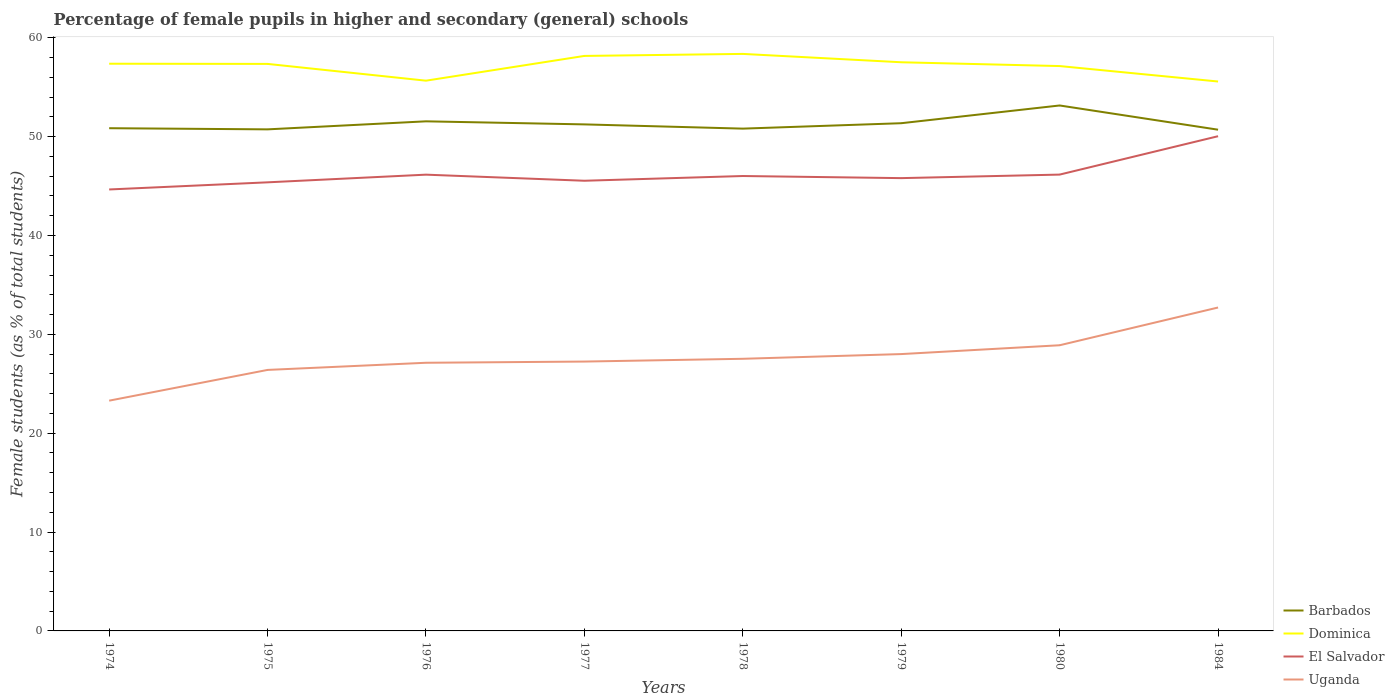Is the number of lines equal to the number of legend labels?
Your response must be concise. Yes. Across all years, what is the maximum percentage of female pupils in higher and secondary schools in Barbados?
Your answer should be compact. 50.71. In which year was the percentage of female pupils in higher and secondary schools in Barbados maximum?
Keep it short and to the point. 1984. What is the total percentage of female pupils in higher and secondary schools in Dominica in the graph?
Provide a succinct answer. -0.15. What is the difference between the highest and the second highest percentage of female pupils in higher and secondary schools in El Salvador?
Offer a terse response. 5.39. What is the difference between the highest and the lowest percentage of female pupils in higher and secondary schools in Uganda?
Your answer should be compact. 3. Is the percentage of female pupils in higher and secondary schools in Uganda strictly greater than the percentage of female pupils in higher and secondary schools in El Salvador over the years?
Ensure brevity in your answer.  Yes. Are the values on the major ticks of Y-axis written in scientific E-notation?
Provide a short and direct response. No. Does the graph contain grids?
Your response must be concise. No. Where does the legend appear in the graph?
Keep it short and to the point. Bottom right. How are the legend labels stacked?
Provide a short and direct response. Vertical. What is the title of the graph?
Offer a very short reply. Percentage of female pupils in higher and secondary (general) schools. What is the label or title of the X-axis?
Give a very brief answer. Years. What is the label or title of the Y-axis?
Provide a short and direct response. Female students (as % of total students). What is the Female students (as % of total students) in Barbados in 1974?
Your answer should be very brief. 50.86. What is the Female students (as % of total students) of Dominica in 1974?
Make the answer very short. 57.38. What is the Female students (as % of total students) of El Salvador in 1974?
Ensure brevity in your answer.  44.66. What is the Female students (as % of total students) of Uganda in 1974?
Provide a short and direct response. 23.29. What is the Female students (as % of total students) of Barbados in 1975?
Your response must be concise. 50.74. What is the Female students (as % of total students) in Dominica in 1975?
Your response must be concise. 57.36. What is the Female students (as % of total students) in El Salvador in 1975?
Give a very brief answer. 45.38. What is the Female students (as % of total students) in Uganda in 1975?
Make the answer very short. 26.4. What is the Female students (as % of total students) of Barbados in 1976?
Make the answer very short. 51.55. What is the Female students (as % of total students) in Dominica in 1976?
Keep it short and to the point. 55.66. What is the Female students (as % of total students) in El Salvador in 1976?
Ensure brevity in your answer.  46.16. What is the Female students (as % of total students) of Uganda in 1976?
Your response must be concise. 27.13. What is the Female students (as % of total students) of Barbados in 1977?
Make the answer very short. 51.24. What is the Female students (as % of total students) in Dominica in 1977?
Ensure brevity in your answer.  58.17. What is the Female students (as % of total students) of El Salvador in 1977?
Make the answer very short. 45.54. What is the Female students (as % of total students) of Uganda in 1977?
Make the answer very short. 27.25. What is the Female students (as % of total students) of Barbados in 1978?
Your response must be concise. 50.81. What is the Female students (as % of total students) of Dominica in 1978?
Keep it short and to the point. 58.37. What is the Female students (as % of total students) of El Salvador in 1978?
Keep it short and to the point. 46.02. What is the Female students (as % of total students) in Uganda in 1978?
Give a very brief answer. 27.53. What is the Female students (as % of total students) in Barbados in 1979?
Your answer should be compact. 51.36. What is the Female students (as % of total students) in Dominica in 1979?
Provide a succinct answer. 57.53. What is the Female students (as % of total students) of El Salvador in 1979?
Your answer should be compact. 45.81. What is the Female students (as % of total students) in Uganda in 1979?
Give a very brief answer. 28.01. What is the Female students (as % of total students) of Barbados in 1980?
Provide a succinct answer. 53.16. What is the Female students (as % of total students) of Dominica in 1980?
Give a very brief answer. 57.14. What is the Female students (as % of total students) in El Salvador in 1980?
Your answer should be compact. 46.16. What is the Female students (as % of total students) in Uganda in 1980?
Your answer should be very brief. 28.9. What is the Female students (as % of total students) in Barbados in 1984?
Offer a terse response. 50.71. What is the Female students (as % of total students) in Dominica in 1984?
Provide a short and direct response. 55.58. What is the Female students (as % of total students) of El Salvador in 1984?
Make the answer very short. 50.05. What is the Female students (as % of total students) in Uganda in 1984?
Offer a very short reply. 32.72. Across all years, what is the maximum Female students (as % of total students) of Barbados?
Ensure brevity in your answer.  53.16. Across all years, what is the maximum Female students (as % of total students) in Dominica?
Make the answer very short. 58.37. Across all years, what is the maximum Female students (as % of total students) in El Salvador?
Offer a very short reply. 50.05. Across all years, what is the maximum Female students (as % of total students) of Uganda?
Give a very brief answer. 32.72. Across all years, what is the minimum Female students (as % of total students) of Barbados?
Your response must be concise. 50.71. Across all years, what is the minimum Female students (as % of total students) in Dominica?
Provide a succinct answer. 55.58. Across all years, what is the minimum Female students (as % of total students) in El Salvador?
Make the answer very short. 44.66. Across all years, what is the minimum Female students (as % of total students) in Uganda?
Offer a terse response. 23.29. What is the total Female students (as % of total students) of Barbados in the graph?
Ensure brevity in your answer.  410.43. What is the total Female students (as % of total students) of Dominica in the graph?
Ensure brevity in your answer.  457.2. What is the total Female students (as % of total students) of El Salvador in the graph?
Keep it short and to the point. 369.77. What is the total Female students (as % of total students) in Uganda in the graph?
Your response must be concise. 221.23. What is the difference between the Female students (as % of total students) in Barbados in 1974 and that in 1975?
Make the answer very short. 0.12. What is the difference between the Female students (as % of total students) of Dominica in 1974 and that in 1975?
Keep it short and to the point. 0.02. What is the difference between the Female students (as % of total students) of El Salvador in 1974 and that in 1975?
Provide a succinct answer. -0.72. What is the difference between the Female students (as % of total students) of Uganda in 1974 and that in 1975?
Give a very brief answer. -3.11. What is the difference between the Female students (as % of total students) in Barbados in 1974 and that in 1976?
Your answer should be compact. -0.69. What is the difference between the Female students (as % of total students) in Dominica in 1974 and that in 1976?
Offer a very short reply. 1.72. What is the difference between the Female students (as % of total students) of El Salvador in 1974 and that in 1976?
Offer a very short reply. -1.5. What is the difference between the Female students (as % of total students) in Uganda in 1974 and that in 1976?
Give a very brief answer. -3.83. What is the difference between the Female students (as % of total students) of Barbados in 1974 and that in 1977?
Your response must be concise. -0.39. What is the difference between the Female students (as % of total students) in Dominica in 1974 and that in 1977?
Offer a terse response. -0.79. What is the difference between the Female students (as % of total students) of El Salvador in 1974 and that in 1977?
Your answer should be very brief. -0.88. What is the difference between the Female students (as % of total students) of Uganda in 1974 and that in 1977?
Provide a short and direct response. -3.96. What is the difference between the Female students (as % of total students) of Barbados in 1974 and that in 1978?
Make the answer very short. 0.04. What is the difference between the Female students (as % of total students) in Dominica in 1974 and that in 1978?
Give a very brief answer. -0.99. What is the difference between the Female students (as % of total students) of El Salvador in 1974 and that in 1978?
Offer a very short reply. -1.36. What is the difference between the Female students (as % of total students) in Uganda in 1974 and that in 1978?
Give a very brief answer. -4.24. What is the difference between the Female students (as % of total students) of Barbados in 1974 and that in 1979?
Ensure brevity in your answer.  -0.5. What is the difference between the Female students (as % of total students) of Dominica in 1974 and that in 1979?
Make the answer very short. -0.15. What is the difference between the Female students (as % of total students) in El Salvador in 1974 and that in 1979?
Offer a very short reply. -1.15. What is the difference between the Female students (as % of total students) in Uganda in 1974 and that in 1979?
Your response must be concise. -4.71. What is the difference between the Female students (as % of total students) in Barbados in 1974 and that in 1980?
Your response must be concise. -2.3. What is the difference between the Female students (as % of total students) of Dominica in 1974 and that in 1980?
Offer a terse response. 0.24. What is the difference between the Female students (as % of total students) of El Salvador in 1974 and that in 1980?
Make the answer very short. -1.51. What is the difference between the Female students (as % of total students) in Uganda in 1974 and that in 1980?
Provide a short and direct response. -5.61. What is the difference between the Female students (as % of total students) in Barbados in 1974 and that in 1984?
Provide a short and direct response. 0.15. What is the difference between the Female students (as % of total students) in El Salvador in 1974 and that in 1984?
Make the answer very short. -5.39. What is the difference between the Female students (as % of total students) in Uganda in 1974 and that in 1984?
Ensure brevity in your answer.  -9.42. What is the difference between the Female students (as % of total students) of Barbados in 1975 and that in 1976?
Offer a very short reply. -0.81. What is the difference between the Female students (as % of total students) in Dominica in 1975 and that in 1976?
Offer a very short reply. 1.7. What is the difference between the Female students (as % of total students) of El Salvador in 1975 and that in 1976?
Provide a succinct answer. -0.78. What is the difference between the Female students (as % of total students) in Uganda in 1975 and that in 1976?
Your answer should be compact. -0.72. What is the difference between the Female students (as % of total students) in Barbados in 1975 and that in 1977?
Ensure brevity in your answer.  -0.5. What is the difference between the Female students (as % of total students) in Dominica in 1975 and that in 1977?
Your answer should be very brief. -0.81. What is the difference between the Female students (as % of total students) of El Salvador in 1975 and that in 1977?
Offer a very short reply. -0.16. What is the difference between the Female students (as % of total students) in Uganda in 1975 and that in 1977?
Ensure brevity in your answer.  -0.84. What is the difference between the Female students (as % of total students) in Barbados in 1975 and that in 1978?
Give a very brief answer. -0.07. What is the difference between the Female students (as % of total students) of Dominica in 1975 and that in 1978?
Your answer should be very brief. -1.01. What is the difference between the Female students (as % of total students) of El Salvador in 1975 and that in 1978?
Provide a short and direct response. -0.64. What is the difference between the Female students (as % of total students) in Uganda in 1975 and that in 1978?
Give a very brief answer. -1.13. What is the difference between the Female students (as % of total students) in Barbados in 1975 and that in 1979?
Make the answer very short. -0.62. What is the difference between the Female students (as % of total students) in Dominica in 1975 and that in 1979?
Provide a succinct answer. -0.17. What is the difference between the Female students (as % of total students) of El Salvador in 1975 and that in 1979?
Ensure brevity in your answer.  -0.42. What is the difference between the Female students (as % of total students) of Uganda in 1975 and that in 1979?
Provide a short and direct response. -1.6. What is the difference between the Female students (as % of total students) of Barbados in 1975 and that in 1980?
Keep it short and to the point. -2.42. What is the difference between the Female students (as % of total students) in Dominica in 1975 and that in 1980?
Give a very brief answer. 0.22. What is the difference between the Female students (as % of total students) in El Salvador in 1975 and that in 1980?
Your answer should be compact. -0.78. What is the difference between the Female students (as % of total students) of Uganda in 1975 and that in 1980?
Offer a very short reply. -2.49. What is the difference between the Female students (as % of total students) of Barbados in 1975 and that in 1984?
Offer a very short reply. 0.03. What is the difference between the Female students (as % of total students) in Dominica in 1975 and that in 1984?
Your answer should be very brief. 1.78. What is the difference between the Female students (as % of total students) in El Salvador in 1975 and that in 1984?
Make the answer very short. -4.67. What is the difference between the Female students (as % of total students) in Uganda in 1975 and that in 1984?
Give a very brief answer. -6.31. What is the difference between the Female students (as % of total students) of Barbados in 1976 and that in 1977?
Offer a terse response. 0.31. What is the difference between the Female students (as % of total students) in Dominica in 1976 and that in 1977?
Make the answer very short. -2.5. What is the difference between the Female students (as % of total students) in El Salvador in 1976 and that in 1977?
Give a very brief answer. 0.62. What is the difference between the Female students (as % of total students) in Uganda in 1976 and that in 1977?
Make the answer very short. -0.12. What is the difference between the Female students (as % of total students) of Barbados in 1976 and that in 1978?
Your answer should be very brief. 0.74. What is the difference between the Female students (as % of total students) of Dominica in 1976 and that in 1978?
Give a very brief answer. -2.71. What is the difference between the Female students (as % of total students) of El Salvador in 1976 and that in 1978?
Provide a short and direct response. 0.14. What is the difference between the Female students (as % of total students) of Uganda in 1976 and that in 1978?
Offer a terse response. -0.4. What is the difference between the Female students (as % of total students) in Barbados in 1976 and that in 1979?
Your answer should be very brief. 0.19. What is the difference between the Female students (as % of total students) of Dominica in 1976 and that in 1979?
Your response must be concise. -1.86. What is the difference between the Female students (as % of total students) of El Salvador in 1976 and that in 1979?
Give a very brief answer. 0.35. What is the difference between the Female students (as % of total students) in Uganda in 1976 and that in 1979?
Give a very brief answer. -0.88. What is the difference between the Female students (as % of total students) in Barbados in 1976 and that in 1980?
Your response must be concise. -1.6. What is the difference between the Female students (as % of total students) in Dominica in 1976 and that in 1980?
Provide a short and direct response. -1.48. What is the difference between the Female students (as % of total students) of El Salvador in 1976 and that in 1980?
Give a very brief answer. -0.01. What is the difference between the Female students (as % of total students) in Uganda in 1976 and that in 1980?
Offer a very short reply. -1.77. What is the difference between the Female students (as % of total students) of Barbados in 1976 and that in 1984?
Offer a terse response. 0.85. What is the difference between the Female students (as % of total students) in Dominica in 1976 and that in 1984?
Offer a terse response. 0.08. What is the difference between the Female students (as % of total students) in El Salvador in 1976 and that in 1984?
Offer a very short reply. -3.89. What is the difference between the Female students (as % of total students) in Uganda in 1976 and that in 1984?
Offer a terse response. -5.59. What is the difference between the Female students (as % of total students) in Barbados in 1977 and that in 1978?
Your answer should be compact. 0.43. What is the difference between the Female students (as % of total students) of Dominica in 1977 and that in 1978?
Offer a terse response. -0.2. What is the difference between the Female students (as % of total students) of El Salvador in 1977 and that in 1978?
Keep it short and to the point. -0.48. What is the difference between the Female students (as % of total students) of Uganda in 1977 and that in 1978?
Your answer should be very brief. -0.28. What is the difference between the Female students (as % of total students) in Barbados in 1977 and that in 1979?
Make the answer very short. -0.12. What is the difference between the Female students (as % of total students) of Dominica in 1977 and that in 1979?
Your response must be concise. 0.64. What is the difference between the Female students (as % of total students) in El Salvador in 1977 and that in 1979?
Your answer should be very brief. -0.27. What is the difference between the Female students (as % of total students) of Uganda in 1977 and that in 1979?
Provide a short and direct response. -0.76. What is the difference between the Female students (as % of total students) in Barbados in 1977 and that in 1980?
Keep it short and to the point. -1.91. What is the difference between the Female students (as % of total students) in Dominica in 1977 and that in 1980?
Your answer should be very brief. 1.03. What is the difference between the Female students (as % of total students) of El Salvador in 1977 and that in 1980?
Keep it short and to the point. -0.62. What is the difference between the Female students (as % of total students) in Uganda in 1977 and that in 1980?
Provide a succinct answer. -1.65. What is the difference between the Female students (as % of total students) in Barbados in 1977 and that in 1984?
Offer a terse response. 0.54. What is the difference between the Female students (as % of total students) of Dominica in 1977 and that in 1984?
Your response must be concise. 2.59. What is the difference between the Female students (as % of total students) in El Salvador in 1977 and that in 1984?
Keep it short and to the point. -4.51. What is the difference between the Female students (as % of total students) in Uganda in 1977 and that in 1984?
Ensure brevity in your answer.  -5.47. What is the difference between the Female students (as % of total students) of Barbados in 1978 and that in 1979?
Keep it short and to the point. -0.55. What is the difference between the Female students (as % of total students) of Dominica in 1978 and that in 1979?
Your response must be concise. 0.84. What is the difference between the Female students (as % of total students) in El Salvador in 1978 and that in 1979?
Offer a terse response. 0.21. What is the difference between the Female students (as % of total students) of Uganda in 1978 and that in 1979?
Offer a very short reply. -0.48. What is the difference between the Female students (as % of total students) of Barbados in 1978 and that in 1980?
Ensure brevity in your answer.  -2.34. What is the difference between the Female students (as % of total students) of Dominica in 1978 and that in 1980?
Offer a terse response. 1.23. What is the difference between the Female students (as % of total students) of El Salvador in 1978 and that in 1980?
Ensure brevity in your answer.  -0.14. What is the difference between the Female students (as % of total students) in Uganda in 1978 and that in 1980?
Your answer should be very brief. -1.37. What is the difference between the Female students (as % of total students) in Barbados in 1978 and that in 1984?
Offer a terse response. 0.11. What is the difference between the Female students (as % of total students) of Dominica in 1978 and that in 1984?
Ensure brevity in your answer.  2.79. What is the difference between the Female students (as % of total students) in El Salvador in 1978 and that in 1984?
Offer a terse response. -4.03. What is the difference between the Female students (as % of total students) in Uganda in 1978 and that in 1984?
Provide a succinct answer. -5.19. What is the difference between the Female students (as % of total students) in Barbados in 1979 and that in 1980?
Offer a terse response. -1.79. What is the difference between the Female students (as % of total students) of Dominica in 1979 and that in 1980?
Make the answer very short. 0.39. What is the difference between the Female students (as % of total students) of El Salvador in 1979 and that in 1980?
Your answer should be very brief. -0.36. What is the difference between the Female students (as % of total students) in Uganda in 1979 and that in 1980?
Ensure brevity in your answer.  -0.89. What is the difference between the Female students (as % of total students) of Barbados in 1979 and that in 1984?
Give a very brief answer. 0.66. What is the difference between the Female students (as % of total students) of Dominica in 1979 and that in 1984?
Provide a short and direct response. 1.95. What is the difference between the Female students (as % of total students) of El Salvador in 1979 and that in 1984?
Offer a very short reply. -4.24. What is the difference between the Female students (as % of total students) of Uganda in 1979 and that in 1984?
Offer a very short reply. -4.71. What is the difference between the Female students (as % of total students) of Barbados in 1980 and that in 1984?
Keep it short and to the point. 2.45. What is the difference between the Female students (as % of total students) in Dominica in 1980 and that in 1984?
Provide a short and direct response. 1.56. What is the difference between the Female students (as % of total students) in El Salvador in 1980 and that in 1984?
Your response must be concise. -3.88. What is the difference between the Female students (as % of total students) of Uganda in 1980 and that in 1984?
Provide a short and direct response. -3.82. What is the difference between the Female students (as % of total students) in Barbados in 1974 and the Female students (as % of total students) in Dominica in 1975?
Give a very brief answer. -6.5. What is the difference between the Female students (as % of total students) in Barbados in 1974 and the Female students (as % of total students) in El Salvador in 1975?
Your answer should be compact. 5.48. What is the difference between the Female students (as % of total students) of Barbados in 1974 and the Female students (as % of total students) of Uganda in 1975?
Your answer should be very brief. 24.45. What is the difference between the Female students (as % of total students) of Dominica in 1974 and the Female students (as % of total students) of El Salvador in 1975?
Offer a very short reply. 12. What is the difference between the Female students (as % of total students) of Dominica in 1974 and the Female students (as % of total students) of Uganda in 1975?
Ensure brevity in your answer.  30.98. What is the difference between the Female students (as % of total students) of El Salvador in 1974 and the Female students (as % of total students) of Uganda in 1975?
Provide a short and direct response. 18.25. What is the difference between the Female students (as % of total students) in Barbados in 1974 and the Female students (as % of total students) in Dominica in 1976?
Offer a terse response. -4.81. What is the difference between the Female students (as % of total students) of Barbados in 1974 and the Female students (as % of total students) of El Salvador in 1976?
Make the answer very short. 4.7. What is the difference between the Female students (as % of total students) in Barbados in 1974 and the Female students (as % of total students) in Uganda in 1976?
Give a very brief answer. 23.73. What is the difference between the Female students (as % of total students) of Dominica in 1974 and the Female students (as % of total students) of El Salvador in 1976?
Keep it short and to the point. 11.22. What is the difference between the Female students (as % of total students) in Dominica in 1974 and the Female students (as % of total students) in Uganda in 1976?
Ensure brevity in your answer.  30.25. What is the difference between the Female students (as % of total students) of El Salvador in 1974 and the Female students (as % of total students) of Uganda in 1976?
Your answer should be compact. 17.53. What is the difference between the Female students (as % of total students) of Barbados in 1974 and the Female students (as % of total students) of Dominica in 1977?
Provide a short and direct response. -7.31. What is the difference between the Female students (as % of total students) of Barbados in 1974 and the Female students (as % of total students) of El Salvador in 1977?
Offer a terse response. 5.32. What is the difference between the Female students (as % of total students) of Barbados in 1974 and the Female students (as % of total students) of Uganda in 1977?
Your answer should be compact. 23.61. What is the difference between the Female students (as % of total students) of Dominica in 1974 and the Female students (as % of total students) of El Salvador in 1977?
Provide a short and direct response. 11.84. What is the difference between the Female students (as % of total students) of Dominica in 1974 and the Female students (as % of total students) of Uganda in 1977?
Your answer should be very brief. 30.13. What is the difference between the Female students (as % of total students) in El Salvador in 1974 and the Female students (as % of total students) in Uganda in 1977?
Your answer should be very brief. 17.41. What is the difference between the Female students (as % of total students) in Barbados in 1974 and the Female students (as % of total students) in Dominica in 1978?
Your response must be concise. -7.51. What is the difference between the Female students (as % of total students) of Barbados in 1974 and the Female students (as % of total students) of El Salvador in 1978?
Keep it short and to the point. 4.84. What is the difference between the Female students (as % of total students) of Barbados in 1974 and the Female students (as % of total students) of Uganda in 1978?
Offer a very short reply. 23.33. What is the difference between the Female students (as % of total students) in Dominica in 1974 and the Female students (as % of total students) in El Salvador in 1978?
Give a very brief answer. 11.36. What is the difference between the Female students (as % of total students) in Dominica in 1974 and the Female students (as % of total students) in Uganda in 1978?
Make the answer very short. 29.85. What is the difference between the Female students (as % of total students) of El Salvador in 1974 and the Female students (as % of total students) of Uganda in 1978?
Your answer should be very brief. 17.13. What is the difference between the Female students (as % of total students) of Barbados in 1974 and the Female students (as % of total students) of Dominica in 1979?
Your response must be concise. -6.67. What is the difference between the Female students (as % of total students) in Barbados in 1974 and the Female students (as % of total students) in El Salvador in 1979?
Your answer should be very brief. 5.05. What is the difference between the Female students (as % of total students) in Barbados in 1974 and the Female students (as % of total students) in Uganda in 1979?
Provide a succinct answer. 22.85. What is the difference between the Female students (as % of total students) of Dominica in 1974 and the Female students (as % of total students) of El Salvador in 1979?
Provide a succinct answer. 11.57. What is the difference between the Female students (as % of total students) of Dominica in 1974 and the Female students (as % of total students) of Uganda in 1979?
Keep it short and to the point. 29.37. What is the difference between the Female students (as % of total students) of El Salvador in 1974 and the Female students (as % of total students) of Uganda in 1979?
Provide a succinct answer. 16.65. What is the difference between the Female students (as % of total students) of Barbados in 1974 and the Female students (as % of total students) of Dominica in 1980?
Give a very brief answer. -6.29. What is the difference between the Female students (as % of total students) of Barbados in 1974 and the Female students (as % of total students) of El Salvador in 1980?
Offer a terse response. 4.69. What is the difference between the Female students (as % of total students) in Barbados in 1974 and the Female students (as % of total students) in Uganda in 1980?
Offer a terse response. 21.96. What is the difference between the Female students (as % of total students) in Dominica in 1974 and the Female students (as % of total students) in El Salvador in 1980?
Give a very brief answer. 11.22. What is the difference between the Female students (as % of total students) of Dominica in 1974 and the Female students (as % of total students) of Uganda in 1980?
Offer a very short reply. 28.48. What is the difference between the Female students (as % of total students) of El Salvador in 1974 and the Female students (as % of total students) of Uganda in 1980?
Offer a terse response. 15.76. What is the difference between the Female students (as % of total students) in Barbados in 1974 and the Female students (as % of total students) in Dominica in 1984?
Provide a short and direct response. -4.72. What is the difference between the Female students (as % of total students) in Barbados in 1974 and the Female students (as % of total students) in El Salvador in 1984?
Give a very brief answer. 0.81. What is the difference between the Female students (as % of total students) in Barbados in 1974 and the Female students (as % of total students) in Uganda in 1984?
Provide a succinct answer. 18.14. What is the difference between the Female students (as % of total students) in Dominica in 1974 and the Female students (as % of total students) in El Salvador in 1984?
Offer a terse response. 7.33. What is the difference between the Female students (as % of total students) of Dominica in 1974 and the Female students (as % of total students) of Uganda in 1984?
Your answer should be compact. 24.66. What is the difference between the Female students (as % of total students) in El Salvador in 1974 and the Female students (as % of total students) in Uganda in 1984?
Make the answer very short. 11.94. What is the difference between the Female students (as % of total students) of Barbados in 1975 and the Female students (as % of total students) of Dominica in 1976?
Your answer should be very brief. -4.92. What is the difference between the Female students (as % of total students) of Barbados in 1975 and the Female students (as % of total students) of El Salvador in 1976?
Keep it short and to the point. 4.58. What is the difference between the Female students (as % of total students) in Barbados in 1975 and the Female students (as % of total students) in Uganda in 1976?
Your response must be concise. 23.61. What is the difference between the Female students (as % of total students) in Dominica in 1975 and the Female students (as % of total students) in El Salvador in 1976?
Offer a very short reply. 11.2. What is the difference between the Female students (as % of total students) in Dominica in 1975 and the Female students (as % of total students) in Uganda in 1976?
Provide a short and direct response. 30.23. What is the difference between the Female students (as % of total students) of El Salvador in 1975 and the Female students (as % of total students) of Uganda in 1976?
Offer a very short reply. 18.25. What is the difference between the Female students (as % of total students) of Barbados in 1975 and the Female students (as % of total students) of Dominica in 1977?
Your answer should be compact. -7.43. What is the difference between the Female students (as % of total students) of Barbados in 1975 and the Female students (as % of total students) of El Salvador in 1977?
Provide a succinct answer. 5.2. What is the difference between the Female students (as % of total students) in Barbados in 1975 and the Female students (as % of total students) in Uganda in 1977?
Make the answer very short. 23.49. What is the difference between the Female students (as % of total students) in Dominica in 1975 and the Female students (as % of total students) in El Salvador in 1977?
Make the answer very short. 11.82. What is the difference between the Female students (as % of total students) of Dominica in 1975 and the Female students (as % of total students) of Uganda in 1977?
Your answer should be compact. 30.11. What is the difference between the Female students (as % of total students) in El Salvador in 1975 and the Female students (as % of total students) in Uganda in 1977?
Make the answer very short. 18.13. What is the difference between the Female students (as % of total students) of Barbados in 1975 and the Female students (as % of total students) of Dominica in 1978?
Offer a terse response. -7.63. What is the difference between the Female students (as % of total students) of Barbados in 1975 and the Female students (as % of total students) of El Salvador in 1978?
Provide a succinct answer. 4.72. What is the difference between the Female students (as % of total students) of Barbados in 1975 and the Female students (as % of total students) of Uganda in 1978?
Your answer should be compact. 23.21. What is the difference between the Female students (as % of total students) of Dominica in 1975 and the Female students (as % of total students) of El Salvador in 1978?
Keep it short and to the point. 11.34. What is the difference between the Female students (as % of total students) of Dominica in 1975 and the Female students (as % of total students) of Uganda in 1978?
Give a very brief answer. 29.83. What is the difference between the Female students (as % of total students) of El Salvador in 1975 and the Female students (as % of total students) of Uganda in 1978?
Offer a terse response. 17.85. What is the difference between the Female students (as % of total students) of Barbados in 1975 and the Female students (as % of total students) of Dominica in 1979?
Keep it short and to the point. -6.79. What is the difference between the Female students (as % of total students) in Barbados in 1975 and the Female students (as % of total students) in El Salvador in 1979?
Your answer should be very brief. 4.93. What is the difference between the Female students (as % of total students) of Barbados in 1975 and the Female students (as % of total students) of Uganda in 1979?
Make the answer very short. 22.73. What is the difference between the Female students (as % of total students) of Dominica in 1975 and the Female students (as % of total students) of El Salvador in 1979?
Give a very brief answer. 11.56. What is the difference between the Female students (as % of total students) of Dominica in 1975 and the Female students (as % of total students) of Uganda in 1979?
Offer a terse response. 29.35. What is the difference between the Female students (as % of total students) in El Salvador in 1975 and the Female students (as % of total students) in Uganda in 1979?
Your answer should be very brief. 17.37. What is the difference between the Female students (as % of total students) in Barbados in 1975 and the Female students (as % of total students) in Dominica in 1980?
Make the answer very short. -6.4. What is the difference between the Female students (as % of total students) in Barbados in 1975 and the Female students (as % of total students) in El Salvador in 1980?
Your response must be concise. 4.58. What is the difference between the Female students (as % of total students) in Barbados in 1975 and the Female students (as % of total students) in Uganda in 1980?
Provide a succinct answer. 21.84. What is the difference between the Female students (as % of total students) in Dominica in 1975 and the Female students (as % of total students) in El Salvador in 1980?
Provide a short and direct response. 11.2. What is the difference between the Female students (as % of total students) of Dominica in 1975 and the Female students (as % of total students) of Uganda in 1980?
Ensure brevity in your answer.  28.46. What is the difference between the Female students (as % of total students) in El Salvador in 1975 and the Female students (as % of total students) in Uganda in 1980?
Your answer should be very brief. 16.48. What is the difference between the Female students (as % of total students) of Barbados in 1975 and the Female students (as % of total students) of Dominica in 1984?
Give a very brief answer. -4.84. What is the difference between the Female students (as % of total students) of Barbados in 1975 and the Female students (as % of total students) of El Salvador in 1984?
Offer a terse response. 0.69. What is the difference between the Female students (as % of total students) in Barbados in 1975 and the Female students (as % of total students) in Uganda in 1984?
Offer a terse response. 18.02. What is the difference between the Female students (as % of total students) in Dominica in 1975 and the Female students (as % of total students) in El Salvador in 1984?
Keep it short and to the point. 7.31. What is the difference between the Female students (as % of total students) of Dominica in 1975 and the Female students (as % of total students) of Uganda in 1984?
Offer a terse response. 24.64. What is the difference between the Female students (as % of total students) of El Salvador in 1975 and the Female students (as % of total students) of Uganda in 1984?
Ensure brevity in your answer.  12.66. What is the difference between the Female students (as % of total students) of Barbados in 1976 and the Female students (as % of total students) of Dominica in 1977?
Offer a terse response. -6.62. What is the difference between the Female students (as % of total students) of Barbados in 1976 and the Female students (as % of total students) of El Salvador in 1977?
Ensure brevity in your answer.  6.01. What is the difference between the Female students (as % of total students) of Barbados in 1976 and the Female students (as % of total students) of Uganda in 1977?
Your answer should be compact. 24.3. What is the difference between the Female students (as % of total students) in Dominica in 1976 and the Female students (as % of total students) in El Salvador in 1977?
Your response must be concise. 10.12. What is the difference between the Female students (as % of total students) in Dominica in 1976 and the Female students (as % of total students) in Uganda in 1977?
Provide a short and direct response. 28.42. What is the difference between the Female students (as % of total students) of El Salvador in 1976 and the Female students (as % of total students) of Uganda in 1977?
Provide a short and direct response. 18.91. What is the difference between the Female students (as % of total students) of Barbados in 1976 and the Female students (as % of total students) of Dominica in 1978?
Ensure brevity in your answer.  -6.82. What is the difference between the Female students (as % of total students) of Barbados in 1976 and the Female students (as % of total students) of El Salvador in 1978?
Provide a short and direct response. 5.53. What is the difference between the Female students (as % of total students) of Barbados in 1976 and the Female students (as % of total students) of Uganda in 1978?
Make the answer very short. 24.02. What is the difference between the Female students (as % of total students) of Dominica in 1976 and the Female students (as % of total students) of El Salvador in 1978?
Offer a very short reply. 9.65. What is the difference between the Female students (as % of total students) of Dominica in 1976 and the Female students (as % of total students) of Uganda in 1978?
Your answer should be very brief. 28.14. What is the difference between the Female students (as % of total students) of El Salvador in 1976 and the Female students (as % of total students) of Uganda in 1978?
Ensure brevity in your answer.  18.63. What is the difference between the Female students (as % of total students) in Barbados in 1976 and the Female students (as % of total students) in Dominica in 1979?
Ensure brevity in your answer.  -5.98. What is the difference between the Female students (as % of total students) in Barbados in 1976 and the Female students (as % of total students) in El Salvador in 1979?
Provide a short and direct response. 5.75. What is the difference between the Female students (as % of total students) of Barbados in 1976 and the Female students (as % of total students) of Uganda in 1979?
Keep it short and to the point. 23.55. What is the difference between the Female students (as % of total students) in Dominica in 1976 and the Female students (as % of total students) in El Salvador in 1979?
Offer a very short reply. 9.86. What is the difference between the Female students (as % of total students) in Dominica in 1976 and the Female students (as % of total students) in Uganda in 1979?
Keep it short and to the point. 27.66. What is the difference between the Female students (as % of total students) of El Salvador in 1976 and the Female students (as % of total students) of Uganda in 1979?
Provide a short and direct response. 18.15. What is the difference between the Female students (as % of total students) of Barbados in 1976 and the Female students (as % of total students) of Dominica in 1980?
Ensure brevity in your answer.  -5.59. What is the difference between the Female students (as % of total students) of Barbados in 1976 and the Female students (as % of total students) of El Salvador in 1980?
Ensure brevity in your answer.  5.39. What is the difference between the Female students (as % of total students) in Barbados in 1976 and the Female students (as % of total students) in Uganda in 1980?
Give a very brief answer. 22.65. What is the difference between the Female students (as % of total students) of Dominica in 1976 and the Female students (as % of total students) of El Salvador in 1980?
Ensure brevity in your answer.  9.5. What is the difference between the Female students (as % of total students) in Dominica in 1976 and the Female students (as % of total students) in Uganda in 1980?
Offer a terse response. 26.77. What is the difference between the Female students (as % of total students) of El Salvador in 1976 and the Female students (as % of total students) of Uganda in 1980?
Provide a succinct answer. 17.26. What is the difference between the Female students (as % of total students) in Barbados in 1976 and the Female students (as % of total students) in Dominica in 1984?
Keep it short and to the point. -4.03. What is the difference between the Female students (as % of total students) of Barbados in 1976 and the Female students (as % of total students) of El Salvador in 1984?
Ensure brevity in your answer.  1.51. What is the difference between the Female students (as % of total students) of Barbados in 1976 and the Female students (as % of total students) of Uganda in 1984?
Offer a very short reply. 18.83. What is the difference between the Female students (as % of total students) of Dominica in 1976 and the Female students (as % of total students) of El Salvador in 1984?
Keep it short and to the point. 5.62. What is the difference between the Female students (as % of total students) in Dominica in 1976 and the Female students (as % of total students) in Uganda in 1984?
Make the answer very short. 22.95. What is the difference between the Female students (as % of total students) of El Salvador in 1976 and the Female students (as % of total students) of Uganda in 1984?
Your answer should be very brief. 13.44. What is the difference between the Female students (as % of total students) in Barbados in 1977 and the Female students (as % of total students) in Dominica in 1978?
Keep it short and to the point. -7.13. What is the difference between the Female students (as % of total students) in Barbados in 1977 and the Female students (as % of total students) in El Salvador in 1978?
Give a very brief answer. 5.22. What is the difference between the Female students (as % of total students) of Barbados in 1977 and the Female students (as % of total students) of Uganda in 1978?
Keep it short and to the point. 23.71. What is the difference between the Female students (as % of total students) of Dominica in 1977 and the Female students (as % of total students) of El Salvador in 1978?
Provide a short and direct response. 12.15. What is the difference between the Female students (as % of total students) in Dominica in 1977 and the Female students (as % of total students) in Uganda in 1978?
Provide a short and direct response. 30.64. What is the difference between the Female students (as % of total students) of El Salvador in 1977 and the Female students (as % of total students) of Uganda in 1978?
Keep it short and to the point. 18.01. What is the difference between the Female students (as % of total students) of Barbados in 1977 and the Female students (as % of total students) of Dominica in 1979?
Provide a succinct answer. -6.28. What is the difference between the Female students (as % of total students) in Barbados in 1977 and the Female students (as % of total students) in El Salvador in 1979?
Your response must be concise. 5.44. What is the difference between the Female students (as % of total students) of Barbados in 1977 and the Female students (as % of total students) of Uganda in 1979?
Offer a terse response. 23.24. What is the difference between the Female students (as % of total students) in Dominica in 1977 and the Female students (as % of total students) in El Salvador in 1979?
Your response must be concise. 12.36. What is the difference between the Female students (as % of total students) of Dominica in 1977 and the Female students (as % of total students) of Uganda in 1979?
Offer a very short reply. 30.16. What is the difference between the Female students (as % of total students) of El Salvador in 1977 and the Female students (as % of total students) of Uganda in 1979?
Give a very brief answer. 17.53. What is the difference between the Female students (as % of total students) in Barbados in 1977 and the Female students (as % of total students) in Dominica in 1980?
Offer a terse response. -5.9. What is the difference between the Female students (as % of total students) of Barbados in 1977 and the Female students (as % of total students) of El Salvador in 1980?
Keep it short and to the point. 5.08. What is the difference between the Female students (as % of total students) of Barbados in 1977 and the Female students (as % of total students) of Uganda in 1980?
Your answer should be compact. 22.34. What is the difference between the Female students (as % of total students) in Dominica in 1977 and the Female students (as % of total students) in El Salvador in 1980?
Give a very brief answer. 12.01. What is the difference between the Female students (as % of total students) in Dominica in 1977 and the Female students (as % of total students) in Uganda in 1980?
Provide a succinct answer. 29.27. What is the difference between the Female students (as % of total students) of El Salvador in 1977 and the Female students (as % of total students) of Uganda in 1980?
Your response must be concise. 16.64. What is the difference between the Female students (as % of total students) of Barbados in 1977 and the Female students (as % of total students) of Dominica in 1984?
Provide a short and direct response. -4.34. What is the difference between the Female students (as % of total students) in Barbados in 1977 and the Female students (as % of total students) in El Salvador in 1984?
Offer a terse response. 1.2. What is the difference between the Female students (as % of total students) of Barbados in 1977 and the Female students (as % of total students) of Uganda in 1984?
Offer a very short reply. 18.53. What is the difference between the Female students (as % of total students) of Dominica in 1977 and the Female students (as % of total students) of El Salvador in 1984?
Offer a terse response. 8.12. What is the difference between the Female students (as % of total students) in Dominica in 1977 and the Female students (as % of total students) in Uganda in 1984?
Your response must be concise. 25.45. What is the difference between the Female students (as % of total students) in El Salvador in 1977 and the Female students (as % of total students) in Uganda in 1984?
Provide a short and direct response. 12.82. What is the difference between the Female students (as % of total students) in Barbados in 1978 and the Female students (as % of total students) in Dominica in 1979?
Make the answer very short. -6.71. What is the difference between the Female students (as % of total students) of Barbados in 1978 and the Female students (as % of total students) of El Salvador in 1979?
Give a very brief answer. 5.01. What is the difference between the Female students (as % of total students) of Barbados in 1978 and the Female students (as % of total students) of Uganda in 1979?
Make the answer very short. 22.81. What is the difference between the Female students (as % of total students) of Dominica in 1978 and the Female students (as % of total students) of El Salvador in 1979?
Your response must be concise. 12.57. What is the difference between the Female students (as % of total students) in Dominica in 1978 and the Female students (as % of total students) in Uganda in 1979?
Keep it short and to the point. 30.37. What is the difference between the Female students (as % of total students) of El Salvador in 1978 and the Female students (as % of total students) of Uganda in 1979?
Offer a very short reply. 18.01. What is the difference between the Female students (as % of total students) in Barbados in 1978 and the Female students (as % of total students) in Dominica in 1980?
Your response must be concise. -6.33. What is the difference between the Female students (as % of total students) of Barbados in 1978 and the Female students (as % of total students) of El Salvador in 1980?
Keep it short and to the point. 4.65. What is the difference between the Female students (as % of total students) of Barbados in 1978 and the Female students (as % of total students) of Uganda in 1980?
Make the answer very short. 21.92. What is the difference between the Female students (as % of total students) in Dominica in 1978 and the Female students (as % of total students) in El Salvador in 1980?
Your response must be concise. 12.21. What is the difference between the Female students (as % of total students) of Dominica in 1978 and the Female students (as % of total students) of Uganda in 1980?
Provide a short and direct response. 29.47. What is the difference between the Female students (as % of total students) of El Salvador in 1978 and the Female students (as % of total students) of Uganda in 1980?
Ensure brevity in your answer.  17.12. What is the difference between the Female students (as % of total students) in Barbados in 1978 and the Female students (as % of total students) in Dominica in 1984?
Ensure brevity in your answer.  -4.77. What is the difference between the Female students (as % of total students) in Barbados in 1978 and the Female students (as % of total students) in El Salvador in 1984?
Ensure brevity in your answer.  0.77. What is the difference between the Female students (as % of total students) of Barbados in 1978 and the Female students (as % of total students) of Uganda in 1984?
Ensure brevity in your answer.  18.1. What is the difference between the Female students (as % of total students) in Dominica in 1978 and the Female students (as % of total students) in El Salvador in 1984?
Your answer should be very brief. 8.33. What is the difference between the Female students (as % of total students) of Dominica in 1978 and the Female students (as % of total students) of Uganda in 1984?
Offer a very short reply. 25.66. What is the difference between the Female students (as % of total students) of El Salvador in 1978 and the Female students (as % of total students) of Uganda in 1984?
Provide a succinct answer. 13.3. What is the difference between the Female students (as % of total students) of Barbados in 1979 and the Female students (as % of total students) of Dominica in 1980?
Ensure brevity in your answer.  -5.78. What is the difference between the Female students (as % of total students) of Barbados in 1979 and the Female students (as % of total students) of El Salvador in 1980?
Keep it short and to the point. 5.2. What is the difference between the Female students (as % of total students) of Barbados in 1979 and the Female students (as % of total students) of Uganda in 1980?
Provide a short and direct response. 22.46. What is the difference between the Female students (as % of total students) in Dominica in 1979 and the Female students (as % of total students) in El Salvador in 1980?
Give a very brief answer. 11.36. What is the difference between the Female students (as % of total students) in Dominica in 1979 and the Female students (as % of total students) in Uganda in 1980?
Your answer should be compact. 28.63. What is the difference between the Female students (as % of total students) in El Salvador in 1979 and the Female students (as % of total students) in Uganda in 1980?
Ensure brevity in your answer.  16.91. What is the difference between the Female students (as % of total students) of Barbados in 1979 and the Female students (as % of total students) of Dominica in 1984?
Offer a very short reply. -4.22. What is the difference between the Female students (as % of total students) of Barbados in 1979 and the Female students (as % of total students) of El Salvador in 1984?
Give a very brief answer. 1.31. What is the difference between the Female students (as % of total students) of Barbados in 1979 and the Female students (as % of total students) of Uganda in 1984?
Give a very brief answer. 18.64. What is the difference between the Female students (as % of total students) of Dominica in 1979 and the Female students (as % of total students) of El Salvador in 1984?
Make the answer very short. 7.48. What is the difference between the Female students (as % of total students) in Dominica in 1979 and the Female students (as % of total students) in Uganda in 1984?
Your answer should be compact. 24.81. What is the difference between the Female students (as % of total students) in El Salvador in 1979 and the Female students (as % of total students) in Uganda in 1984?
Provide a short and direct response. 13.09. What is the difference between the Female students (as % of total students) in Barbados in 1980 and the Female students (as % of total students) in Dominica in 1984?
Provide a short and direct response. -2.42. What is the difference between the Female students (as % of total students) in Barbados in 1980 and the Female students (as % of total students) in El Salvador in 1984?
Your response must be concise. 3.11. What is the difference between the Female students (as % of total students) of Barbados in 1980 and the Female students (as % of total students) of Uganda in 1984?
Your response must be concise. 20.44. What is the difference between the Female students (as % of total students) of Dominica in 1980 and the Female students (as % of total students) of El Salvador in 1984?
Your answer should be compact. 7.1. What is the difference between the Female students (as % of total students) in Dominica in 1980 and the Female students (as % of total students) in Uganda in 1984?
Ensure brevity in your answer.  24.43. What is the difference between the Female students (as % of total students) of El Salvador in 1980 and the Female students (as % of total students) of Uganda in 1984?
Give a very brief answer. 13.45. What is the average Female students (as % of total students) in Barbados per year?
Provide a succinct answer. 51.3. What is the average Female students (as % of total students) in Dominica per year?
Offer a terse response. 57.15. What is the average Female students (as % of total students) in El Salvador per year?
Provide a short and direct response. 46.22. What is the average Female students (as % of total students) of Uganda per year?
Ensure brevity in your answer.  27.65. In the year 1974, what is the difference between the Female students (as % of total students) in Barbados and Female students (as % of total students) in Dominica?
Your answer should be very brief. -6.52. In the year 1974, what is the difference between the Female students (as % of total students) of Barbados and Female students (as % of total students) of El Salvador?
Make the answer very short. 6.2. In the year 1974, what is the difference between the Female students (as % of total students) in Barbados and Female students (as % of total students) in Uganda?
Provide a succinct answer. 27.56. In the year 1974, what is the difference between the Female students (as % of total students) in Dominica and Female students (as % of total students) in El Salvador?
Make the answer very short. 12.72. In the year 1974, what is the difference between the Female students (as % of total students) in Dominica and Female students (as % of total students) in Uganda?
Your answer should be compact. 34.09. In the year 1974, what is the difference between the Female students (as % of total students) in El Salvador and Female students (as % of total students) in Uganda?
Your answer should be compact. 21.37. In the year 1975, what is the difference between the Female students (as % of total students) in Barbados and Female students (as % of total students) in Dominica?
Keep it short and to the point. -6.62. In the year 1975, what is the difference between the Female students (as % of total students) of Barbados and Female students (as % of total students) of El Salvador?
Ensure brevity in your answer.  5.36. In the year 1975, what is the difference between the Female students (as % of total students) of Barbados and Female students (as % of total students) of Uganda?
Provide a short and direct response. 24.34. In the year 1975, what is the difference between the Female students (as % of total students) of Dominica and Female students (as % of total students) of El Salvador?
Offer a very short reply. 11.98. In the year 1975, what is the difference between the Female students (as % of total students) of Dominica and Female students (as % of total students) of Uganda?
Provide a short and direct response. 30.96. In the year 1975, what is the difference between the Female students (as % of total students) in El Salvador and Female students (as % of total students) in Uganda?
Offer a terse response. 18.98. In the year 1976, what is the difference between the Female students (as % of total students) of Barbados and Female students (as % of total students) of Dominica?
Your answer should be very brief. -4.11. In the year 1976, what is the difference between the Female students (as % of total students) in Barbados and Female students (as % of total students) in El Salvador?
Provide a succinct answer. 5.39. In the year 1976, what is the difference between the Female students (as % of total students) in Barbados and Female students (as % of total students) in Uganda?
Offer a very short reply. 24.43. In the year 1976, what is the difference between the Female students (as % of total students) of Dominica and Female students (as % of total students) of El Salvador?
Provide a succinct answer. 9.51. In the year 1976, what is the difference between the Female students (as % of total students) in Dominica and Female students (as % of total students) in Uganda?
Provide a short and direct response. 28.54. In the year 1976, what is the difference between the Female students (as % of total students) in El Salvador and Female students (as % of total students) in Uganda?
Your response must be concise. 19.03. In the year 1977, what is the difference between the Female students (as % of total students) of Barbados and Female students (as % of total students) of Dominica?
Offer a very short reply. -6.93. In the year 1977, what is the difference between the Female students (as % of total students) of Barbados and Female students (as % of total students) of El Salvador?
Offer a very short reply. 5.7. In the year 1977, what is the difference between the Female students (as % of total students) of Barbados and Female students (as % of total students) of Uganda?
Provide a short and direct response. 23.99. In the year 1977, what is the difference between the Female students (as % of total students) of Dominica and Female students (as % of total students) of El Salvador?
Offer a very short reply. 12.63. In the year 1977, what is the difference between the Female students (as % of total students) of Dominica and Female students (as % of total students) of Uganda?
Provide a short and direct response. 30.92. In the year 1977, what is the difference between the Female students (as % of total students) of El Salvador and Female students (as % of total students) of Uganda?
Provide a succinct answer. 18.29. In the year 1978, what is the difference between the Female students (as % of total students) in Barbados and Female students (as % of total students) in Dominica?
Your response must be concise. -7.56. In the year 1978, what is the difference between the Female students (as % of total students) in Barbados and Female students (as % of total students) in El Salvador?
Provide a succinct answer. 4.79. In the year 1978, what is the difference between the Female students (as % of total students) in Barbados and Female students (as % of total students) in Uganda?
Ensure brevity in your answer.  23.28. In the year 1978, what is the difference between the Female students (as % of total students) in Dominica and Female students (as % of total students) in El Salvador?
Ensure brevity in your answer.  12.35. In the year 1978, what is the difference between the Female students (as % of total students) of Dominica and Female students (as % of total students) of Uganda?
Your answer should be very brief. 30.84. In the year 1978, what is the difference between the Female students (as % of total students) of El Salvador and Female students (as % of total students) of Uganda?
Your response must be concise. 18.49. In the year 1979, what is the difference between the Female students (as % of total students) of Barbados and Female students (as % of total students) of Dominica?
Provide a short and direct response. -6.17. In the year 1979, what is the difference between the Female students (as % of total students) in Barbados and Female students (as % of total students) in El Salvador?
Your answer should be compact. 5.56. In the year 1979, what is the difference between the Female students (as % of total students) of Barbados and Female students (as % of total students) of Uganda?
Make the answer very short. 23.35. In the year 1979, what is the difference between the Female students (as % of total students) in Dominica and Female students (as % of total students) in El Salvador?
Keep it short and to the point. 11.72. In the year 1979, what is the difference between the Female students (as % of total students) of Dominica and Female students (as % of total students) of Uganda?
Your answer should be compact. 29.52. In the year 1979, what is the difference between the Female students (as % of total students) in El Salvador and Female students (as % of total students) in Uganda?
Ensure brevity in your answer.  17.8. In the year 1980, what is the difference between the Female students (as % of total students) in Barbados and Female students (as % of total students) in Dominica?
Your answer should be very brief. -3.99. In the year 1980, what is the difference between the Female students (as % of total students) of Barbados and Female students (as % of total students) of El Salvador?
Your answer should be compact. 6.99. In the year 1980, what is the difference between the Female students (as % of total students) in Barbados and Female students (as % of total students) in Uganda?
Offer a very short reply. 24.26. In the year 1980, what is the difference between the Female students (as % of total students) of Dominica and Female students (as % of total students) of El Salvador?
Keep it short and to the point. 10.98. In the year 1980, what is the difference between the Female students (as % of total students) in Dominica and Female students (as % of total students) in Uganda?
Keep it short and to the point. 28.24. In the year 1980, what is the difference between the Female students (as % of total students) of El Salvador and Female students (as % of total students) of Uganda?
Provide a short and direct response. 17.27. In the year 1984, what is the difference between the Female students (as % of total students) of Barbados and Female students (as % of total students) of Dominica?
Your response must be concise. -4.87. In the year 1984, what is the difference between the Female students (as % of total students) of Barbados and Female students (as % of total students) of El Salvador?
Ensure brevity in your answer.  0.66. In the year 1984, what is the difference between the Female students (as % of total students) in Barbados and Female students (as % of total students) in Uganda?
Provide a short and direct response. 17.99. In the year 1984, what is the difference between the Female students (as % of total students) in Dominica and Female students (as % of total students) in El Salvador?
Offer a very short reply. 5.53. In the year 1984, what is the difference between the Female students (as % of total students) in Dominica and Female students (as % of total students) in Uganda?
Your answer should be compact. 22.86. In the year 1984, what is the difference between the Female students (as % of total students) of El Salvador and Female students (as % of total students) of Uganda?
Offer a terse response. 17.33. What is the ratio of the Female students (as % of total students) of Barbados in 1974 to that in 1975?
Keep it short and to the point. 1. What is the ratio of the Female students (as % of total students) of Dominica in 1974 to that in 1975?
Ensure brevity in your answer.  1. What is the ratio of the Female students (as % of total students) of El Salvador in 1974 to that in 1975?
Your answer should be compact. 0.98. What is the ratio of the Female students (as % of total students) of Uganda in 1974 to that in 1975?
Your answer should be very brief. 0.88. What is the ratio of the Female students (as % of total students) in Barbados in 1974 to that in 1976?
Make the answer very short. 0.99. What is the ratio of the Female students (as % of total students) of Dominica in 1974 to that in 1976?
Your response must be concise. 1.03. What is the ratio of the Female students (as % of total students) of El Salvador in 1974 to that in 1976?
Make the answer very short. 0.97. What is the ratio of the Female students (as % of total students) in Uganda in 1974 to that in 1976?
Ensure brevity in your answer.  0.86. What is the ratio of the Female students (as % of total students) in Barbados in 1974 to that in 1977?
Your answer should be compact. 0.99. What is the ratio of the Female students (as % of total students) of Dominica in 1974 to that in 1977?
Your answer should be very brief. 0.99. What is the ratio of the Female students (as % of total students) in El Salvador in 1974 to that in 1977?
Offer a terse response. 0.98. What is the ratio of the Female students (as % of total students) in Uganda in 1974 to that in 1977?
Give a very brief answer. 0.85. What is the ratio of the Female students (as % of total students) of Barbados in 1974 to that in 1978?
Keep it short and to the point. 1. What is the ratio of the Female students (as % of total students) in El Salvador in 1974 to that in 1978?
Your response must be concise. 0.97. What is the ratio of the Female students (as % of total students) in Uganda in 1974 to that in 1978?
Provide a succinct answer. 0.85. What is the ratio of the Female students (as % of total students) of Barbados in 1974 to that in 1979?
Offer a terse response. 0.99. What is the ratio of the Female students (as % of total students) of Uganda in 1974 to that in 1979?
Give a very brief answer. 0.83. What is the ratio of the Female students (as % of total students) in Barbados in 1974 to that in 1980?
Give a very brief answer. 0.96. What is the ratio of the Female students (as % of total students) of Dominica in 1974 to that in 1980?
Keep it short and to the point. 1. What is the ratio of the Female students (as % of total students) of El Salvador in 1974 to that in 1980?
Make the answer very short. 0.97. What is the ratio of the Female students (as % of total students) in Uganda in 1974 to that in 1980?
Offer a terse response. 0.81. What is the ratio of the Female students (as % of total students) of Barbados in 1974 to that in 1984?
Your response must be concise. 1. What is the ratio of the Female students (as % of total students) in Dominica in 1974 to that in 1984?
Give a very brief answer. 1.03. What is the ratio of the Female students (as % of total students) in El Salvador in 1974 to that in 1984?
Offer a terse response. 0.89. What is the ratio of the Female students (as % of total students) of Uganda in 1974 to that in 1984?
Your answer should be very brief. 0.71. What is the ratio of the Female students (as % of total students) of Barbados in 1975 to that in 1976?
Keep it short and to the point. 0.98. What is the ratio of the Female students (as % of total students) in Dominica in 1975 to that in 1976?
Make the answer very short. 1.03. What is the ratio of the Female students (as % of total students) in El Salvador in 1975 to that in 1976?
Offer a very short reply. 0.98. What is the ratio of the Female students (as % of total students) of Uganda in 1975 to that in 1976?
Keep it short and to the point. 0.97. What is the ratio of the Female students (as % of total students) of Barbados in 1975 to that in 1977?
Your answer should be compact. 0.99. What is the ratio of the Female students (as % of total students) in Dominica in 1975 to that in 1977?
Ensure brevity in your answer.  0.99. What is the ratio of the Female students (as % of total students) in El Salvador in 1975 to that in 1977?
Provide a short and direct response. 1. What is the ratio of the Female students (as % of total students) in Uganda in 1975 to that in 1977?
Provide a short and direct response. 0.97. What is the ratio of the Female students (as % of total students) in Dominica in 1975 to that in 1978?
Your answer should be compact. 0.98. What is the ratio of the Female students (as % of total students) of El Salvador in 1975 to that in 1978?
Offer a very short reply. 0.99. What is the ratio of the Female students (as % of total students) of Uganda in 1975 to that in 1978?
Provide a short and direct response. 0.96. What is the ratio of the Female students (as % of total students) in Barbados in 1975 to that in 1979?
Make the answer very short. 0.99. What is the ratio of the Female students (as % of total students) of Dominica in 1975 to that in 1979?
Ensure brevity in your answer.  1. What is the ratio of the Female students (as % of total students) of Uganda in 1975 to that in 1979?
Provide a succinct answer. 0.94. What is the ratio of the Female students (as % of total students) of Barbados in 1975 to that in 1980?
Your response must be concise. 0.95. What is the ratio of the Female students (as % of total students) in Dominica in 1975 to that in 1980?
Give a very brief answer. 1. What is the ratio of the Female students (as % of total students) in El Salvador in 1975 to that in 1980?
Keep it short and to the point. 0.98. What is the ratio of the Female students (as % of total students) of Uganda in 1975 to that in 1980?
Provide a short and direct response. 0.91. What is the ratio of the Female students (as % of total students) of Barbados in 1975 to that in 1984?
Offer a very short reply. 1. What is the ratio of the Female students (as % of total students) in Dominica in 1975 to that in 1984?
Give a very brief answer. 1.03. What is the ratio of the Female students (as % of total students) in El Salvador in 1975 to that in 1984?
Your response must be concise. 0.91. What is the ratio of the Female students (as % of total students) in Uganda in 1975 to that in 1984?
Provide a short and direct response. 0.81. What is the ratio of the Female students (as % of total students) in Dominica in 1976 to that in 1977?
Give a very brief answer. 0.96. What is the ratio of the Female students (as % of total students) in El Salvador in 1976 to that in 1977?
Your response must be concise. 1.01. What is the ratio of the Female students (as % of total students) of Barbados in 1976 to that in 1978?
Your response must be concise. 1.01. What is the ratio of the Female students (as % of total students) in Dominica in 1976 to that in 1978?
Offer a terse response. 0.95. What is the ratio of the Female students (as % of total students) of Uganda in 1976 to that in 1978?
Your answer should be very brief. 0.99. What is the ratio of the Female students (as % of total students) in Barbados in 1976 to that in 1979?
Keep it short and to the point. 1. What is the ratio of the Female students (as % of total students) of Dominica in 1976 to that in 1979?
Offer a very short reply. 0.97. What is the ratio of the Female students (as % of total students) of El Salvador in 1976 to that in 1979?
Keep it short and to the point. 1.01. What is the ratio of the Female students (as % of total students) in Uganda in 1976 to that in 1979?
Make the answer very short. 0.97. What is the ratio of the Female students (as % of total students) in Barbados in 1976 to that in 1980?
Offer a terse response. 0.97. What is the ratio of the Female students (as % of total students) of Dominica in 1976 to that in 1980?
Your answer should be compact. 0.97. What is the ratio of the Female students (as % of total students) of Uganda in 1976 to that in 1980?
Ensure brevity in your answer.  0.94. What is the ratio of the Female students (as % of total students) in Barbados in 1976 to that in 1984?
Provide a short and direct response. 1.02. What is the ratio of the Female students (as % of total students) of El Salvador in 1976 to that in 1984?
Provide a short and direct response. 0.92. What is the ratio of the Female students (as % of total students) of Uganda in 1976 to that in 1984?
Provide a succinct answer. 0.83. What is the ratio of the Female students (as % of total students) in Barbados in 1977 to that in 1978?
Your answer should be compact. 1.01. What is the ratio of the Female students (as % of total students) of El Salvador in 1977 to that in 1978?
Make the answer very short. 0.99. What is the ratio of the Female students (as % of total students) in Uganda in 1977 to that in 1978?
Provide a short and direct response. 0.99. What is the ratio of the Female students (as % of total students) of Dominica in 1977 to that in 1979?
Keep it short and to the point. 1.01. What is the ratio of the Female students (as % of total students) of Uganda in 1977 to that in 1979?
Your response must be concise. 0.97. What is the ratio of the Female students (as % of total students) of El Salvador in 1977 to that in 1980?
Make the answer very short. 0.99. What is the ratio of the Female students (as % of total students) in Uganda in 1977 to that in 1980?
Offer a terse response. 0.94. What is the ratio of the Female students (as % of total students) of Barbados in 1977 to that in 1984?
Give a very brief answer. 1.01. What is the ratio of the Female students (as % of total students) in Dominica in 1977 to that in 1984?
Make the answer very short. 1.05. What is the ratio of the Female students (as % of total students) in El Salvador in 1977 to that in 1984?
Your answer should be very brief. 0.91. What is the ratio of the Female students (as % of total students) of Uganda in 1977 to that in 1984?
Your answer should be very brief. 0.83. What is the ratio of the Female students (as % of total students) in Barbados in 1978 to that in 1979?
Your answer should be very brief. 0.99. What is the ratio of the Female students (as % of total students) of Dominica in 1978 to that in 1979?
Offer a very short reply. 1.01. What is the ratio of the Female students (as % of total students) of El Salvador in 1978 to that in 1979?
Offer a very short reply. 1. What is the ratio of the Female students (as % of total students) in Uganda in 1978 to that in 1979?
Offer a very short reply. 0.98. What is the ratio of the Female students (as % of total students) of Barbados in 1978 to that in 1980?
Make the answer very short. 0.96. What is the ratio of the Female students (as % of total students) of Dominica in 1978 to that in 1980?
Give a very brief answer. 1.02. What is the ratio of the Female students (as % of total students) of Uganda in 1978 to that in 1980?
Offer a very short reply. 0.95. What is the ratio of the Female students (as % of total students) of Dominica in 1978 to that in 1984?
Offer a terse response. 1.05. What is the ratio of the Female students (as % of total students) of El Salvador in 1978 to that in 1984?
Your answer should be very brief. 0.92. What is the ratio of the Female students (as % of total students) in Uganda in 1978 to that in 1984?
Offer a very short reply. 0.84. What is the ratio of the Female students (as % of total students) of Barbados in 1979 to that in 1980?
Offer a terse response. 0.97. What is the ratio of the Female students (as % of total students) in El Salvador in 1979 to that in 1980?
Provide a succinct answer. 0.99. What is the ratio of the Female students (as % of total students) of Uganda in 1979 to that in 1980?
Your answer should be compact. 0.97. What is the ratio of the Female students (as % of total students) in Barbados in 1979 to that in 1984?
Your answer should be very brief. 1.01. What is the ratio of the Female students (as % of total students) of Dominica in 1979 to that in 1984?
Give a very brief answer. 1.03. What is the ratio of the Female students (as % of total students) of El Salvador in 1979 to that in 1984?
Your answer should be very brief. 0.92. What is the ratio of the Female students (as % of total students) of Uganda in 1979 to that in 1984?
Your response must be concise. 0.86. What is the ratio of the Female students (as % of total students) of Barbados in 1980 to that in 1984?
Ensure brevity in your answer.  1.05. What is the ratio of the Female students (as % of total students) of Dominica in 1980 to that in 1984?
Your response must be concise. 1.03. What is the ratio of the Female students (as % of total students) in El Salvador in 1980 to that in 1984?
Your response must be concise. 0.92. What is the ratio of the Female students (as % of total students) in Uganda in 1980 to that in 1984?
Give a very brief answer. 0.88. What is the difference between the highest and the second highest Female students (as % of total students) in Barbados?
Your response must be concise. 1.6. What is the difference between the highest and the second highest Female students (as % of total students) in Dominica?
Give a very brief answer. 0.2. What is the difference between the highest and the second highest Female students (as % of total students) in El Salvador?
Keep it short and to the point. 3.88. What is the difference between the highest and the second highest Female students (as % of total students) in Uganda?
Provide a short and direct response. 3.82. What is the difference between the highest and the lowest Female students (as % of total students) of Barbados?
Offer a terse response. 2.45. What is the difference between the highest and the lowest Female students (as % of total students) of Dominica?
Give a very brief answer. 2.79. What is the difference between the highest and the lowest Female students (as % of total students) of El Salvador?
Ensure brevity in your answer.  5.39. What is the difference between the highest and the lowest Female students (as % of total students) of Uganda?
Your answer should be compact. 9.42. 